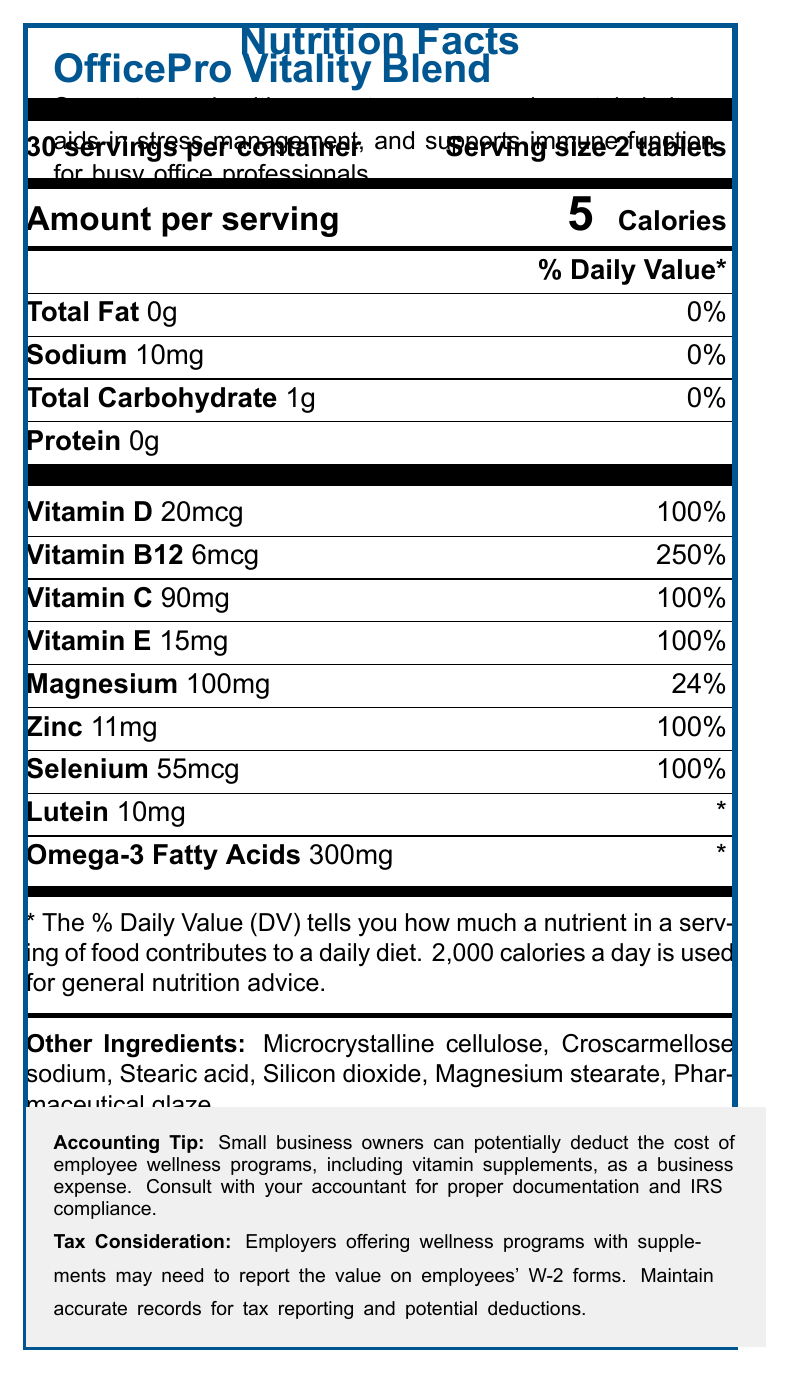what is the serving size for OfficePro Vitality Blend? The nutrition facts label specifies that the serving size for OfficePro Vitality Blend is 2 tablets.
Answer: 2 tablets How many calories are in a serving of OfficePro Vitality Blend? According to the label, there are 5 calories per serving.
Answer: 5 calories What percentage of daily value of Vitamin B12 does OfficePro Vitality Blend provide? The nutrition label indicates that OfficePro Vitality Blend provides 250% of the daily value for Vitamin B12.
Answer: 250% How much sodium is in one serving of OfficePro Vitality Blend? The nutrition facts list sodium content as 10mg per serving.
Answer: 10mg What are the main ingredients in OfficePro Vitality Blend besides vitamins and minerals? These are listed under "Other Ingredients" in the nutrition facts.
Answer: Microcrystalline cellulose, Croscarmellose sodium, Stearic acid, Silicon dioxide, Magnesium stearate, Pharmaceutical glaze How many servings are there per container of OfficePro Vitality Blend? A. 15 B. 20 C. 30 D. 60 The label states that there are 30 servings per container.
Answer: C Which of the following is a marketing claim for OfficePro Vitality Blend? 1. Enhances cardiovascular health 2. Supports eye health for long hours of screen time 3. Helps with weight loss 4. Improves sleep quality The marketing claims section mentions that it supports eye health for long hours of screen time.
Answer: 2 Is there any allergen information provided on the label? The label states that the product contains fish (source of Omega-3 fatty acids).
Answer: Yes Does OfficePro Vitality Blend help with managing stress? One of the marketing claims is that it aids in stress management for busy professionals.
Answer: Yes Summarize the main purpose of OfficePro Vitality Blend based on the document. The product offers a comprehensive blend of vitamins and minerals aimed at promoting well-being for individuals in sedentary office jobs, emphasizing benefits like eye health, energy, mental clarity, stress management, and immune function.
Answer: Provides vitamins and minerals tailored for sedentary office professionals to support eye health, energy, mental clarity, stress management, and immune function. What is the amount of Omega-3 Fatty Acids in a serving of OfficePro Vitality Blend? The nutrition facts indicate that there are 300mg of Omega-3 Fatty Acids per serving.
Answer: 300mg How much Vitamin C does one serving of OfficePro Vitality Blend provide? A. 60mg B. 75mg C. 90mg D. 100mg The document specifies that one serving provides 90mg of Vitamin C.
Answer: C Can the deduction of wellness programs that include vitamin supplements always be applied as a business expense? The document states that small business owners can potentially deduct these costs but advises consulting an accountant for proper documentation and IRS compliance.
Answer: Not enough information What safety precautions are listed for the use of OfficePro Vitality Blend? The warnings on the label include keeping the supplement out of reach of children, storing it in a cool, dry place, and ensuring the seal under the cap is intact before use.
Answer: Keep out of reach of children, store in a cool, dry place, do not use if seal under cap is broken or missing. What is the daily value percentage for Zinc provided by OfficePro Vitality Blend? The nutrition facts indicate that one serving provides 100% of the daily value for Zinc.
Answer: 100% 